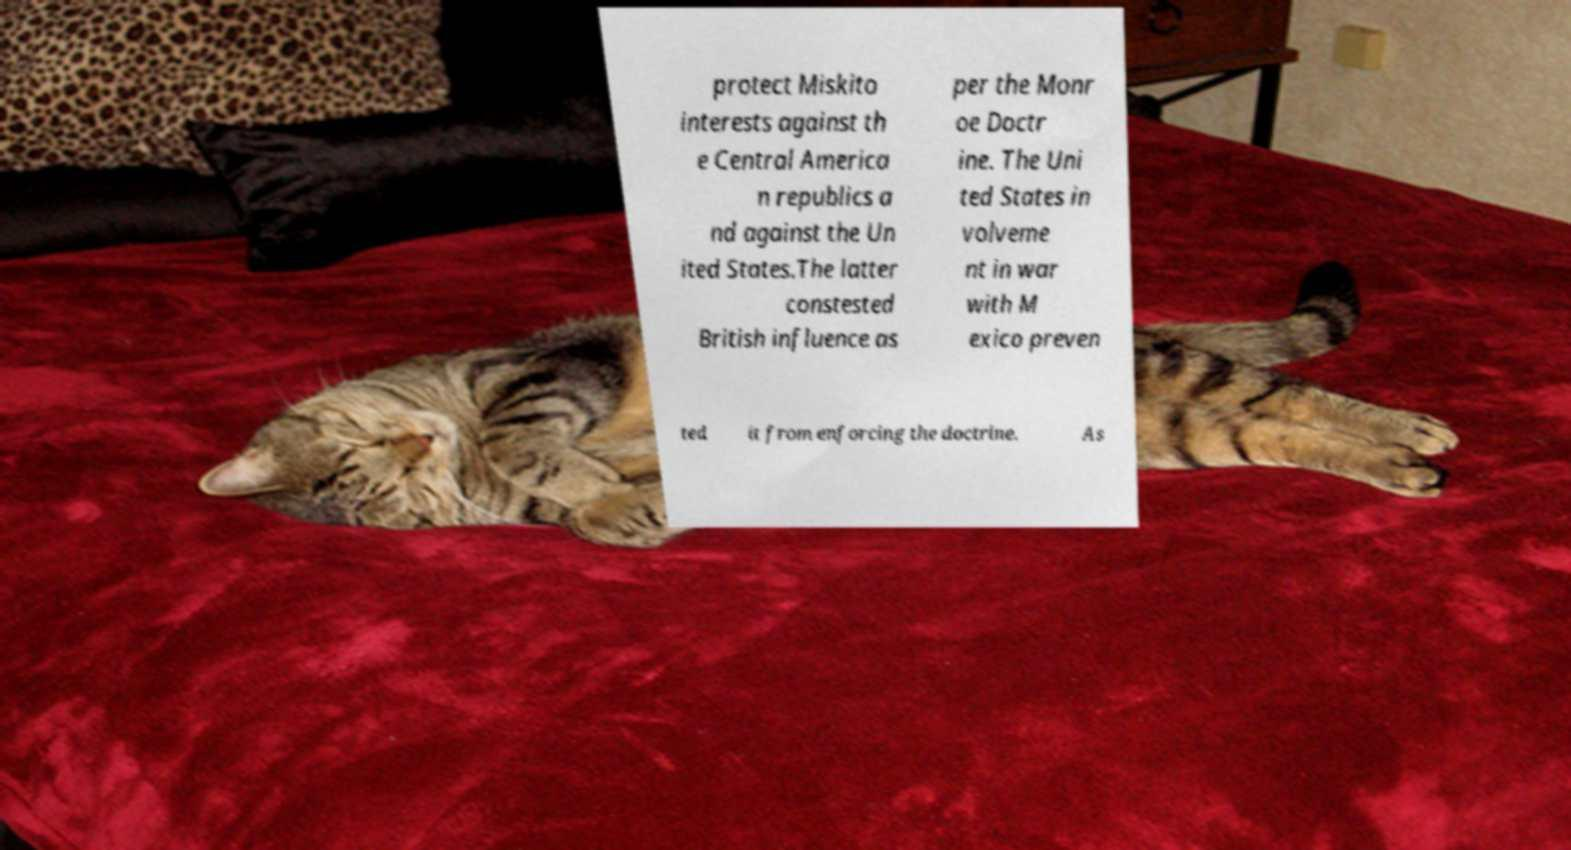Could you extract and type out the text from this image? protect Miskito interests against th e Central America n republics a nd against the Un ited States.The latter constested British influence as per the Monr oe Doctr ine. The Uni ted States in volveme nt in war with M exico preven ted it from enforcing the doctrine. As 